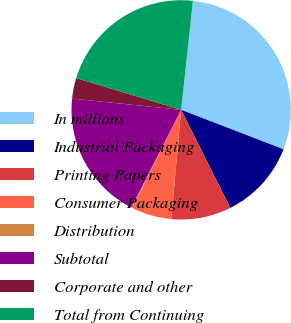Convert chart to OTSL. <chart><loc_0><loc_0><loc_500><loc_500><pie_chart><fcel>In millions<fcel>Industrial Packaging<fcel>Printing Papers<fcel>Consumer Packaging<fcel>Distribution<fcel>Subtotal<fcel>Corporate and other<fcel>Total from Continuing<nl><fcel>29.14%<fcel>11.74%<fcel>8.84%<fcel>5.94%<fcel>0.14%<fcel>19.12%<fcel>3.04%<fcel>22.02%<nl></chart> 